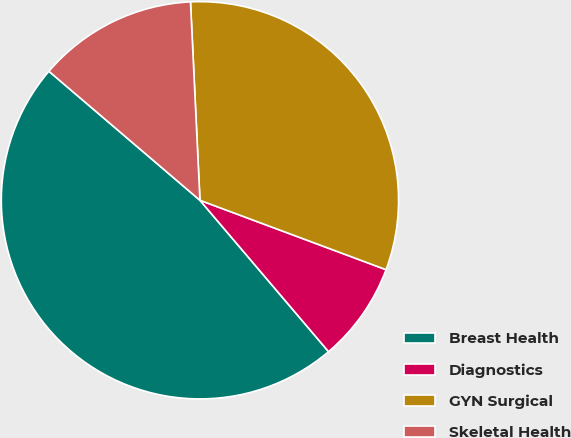Convert chart. <chart><loc_0><loc_0><loc_500><loc_500><pie_chart><fcel>Breast Health<fcel>Diagnostics<fcel>GYN Surgical<fcel>Skeletal Health<nl><fcel>47.46%<fcel>8.11%<fcel>31.44%<fcel>12.99%<nl></chart> 